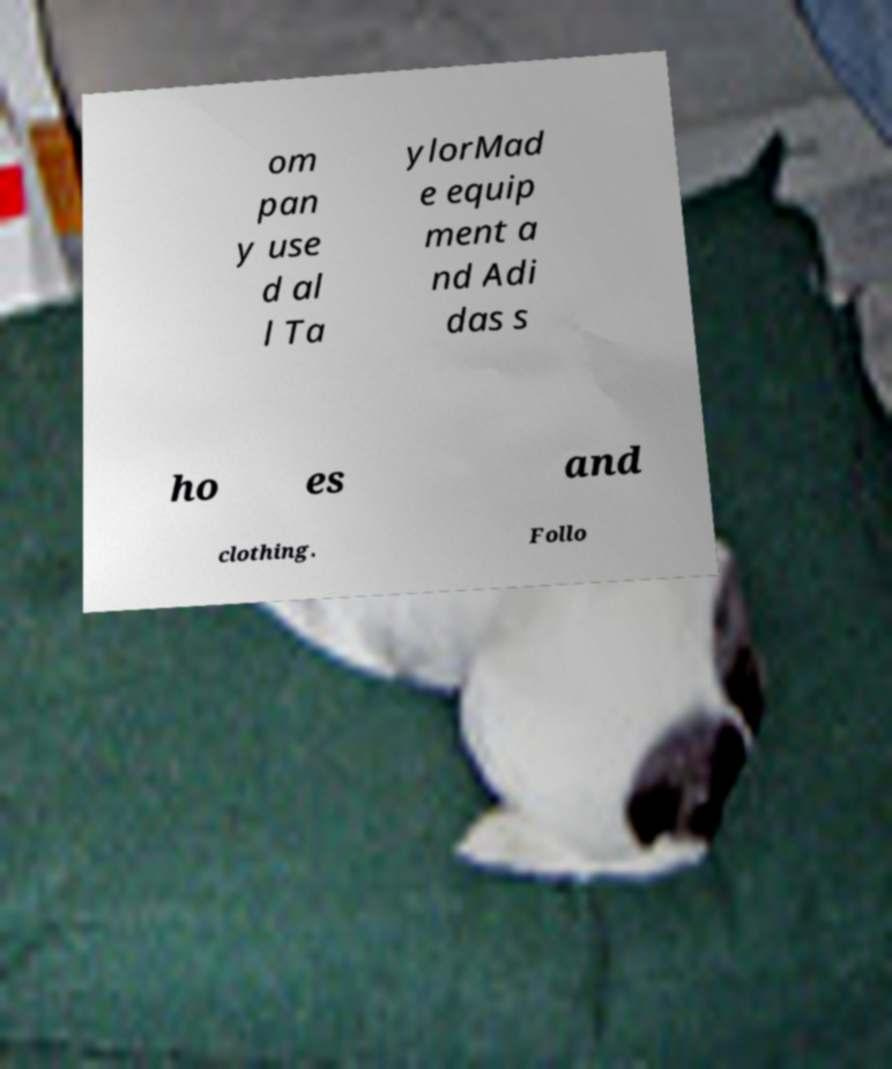Can you accurately transcribe the text from the provided image for me? om pan y use d al l Ta ylorMad e equip ment a nd Adi das s ho es and clothing. Follo 